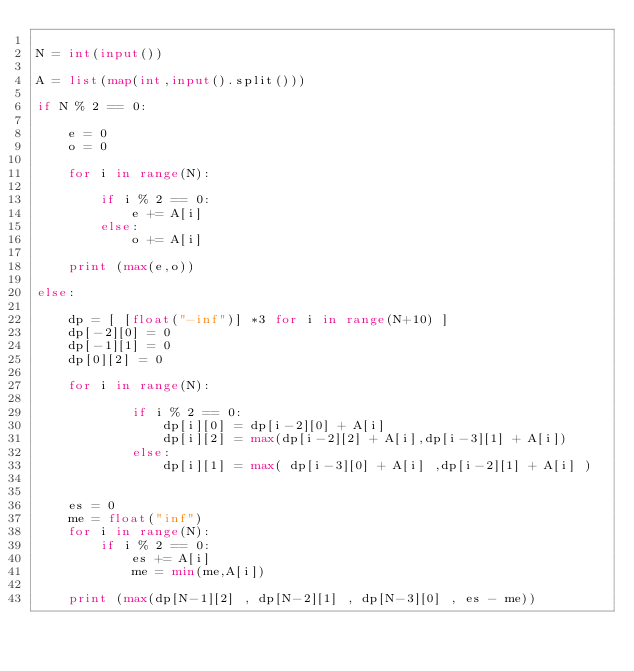Convert code to text. <code><loc_0><loc_0><loc_500><loc_500><_Python_>
N = int(input())

A = list(map(int,input().split()))

if N % 2 == 0:

    e = 0
    o = 0

    for i in range(N):

        if i % 2 == 0:
            e += A[i]
        else:
            o += A[i]

    print (max(e,o))

else:

    dp = [ [float("-inf")] *3 for i in range(N+10) ]
    dp[-2][0] = 0
    dp[-1][1] = 0
    dp[0][2] = 0

    for i in range(N):

            if i % 2 == 0:
                dp[i][0] = dp[i-2][0] + A[i]
                dp[i][2] = max(dp[i-2][2] + A[i],dp[i-3][1] + A[i])
            else:
                dp[i][1] = max( dp[i-3][0] + A[i] ,dp[i-2][1] + A[i] )


    es = 0
    me = float("inf")
    for i in range(N):
        if i % 2 == 0:
            es += A[i]
            me = min(me,A[i])

    print (max(dp[N-1][2] , dp[N-2][1] , dp[N-3][0] , es - me))
</code> 